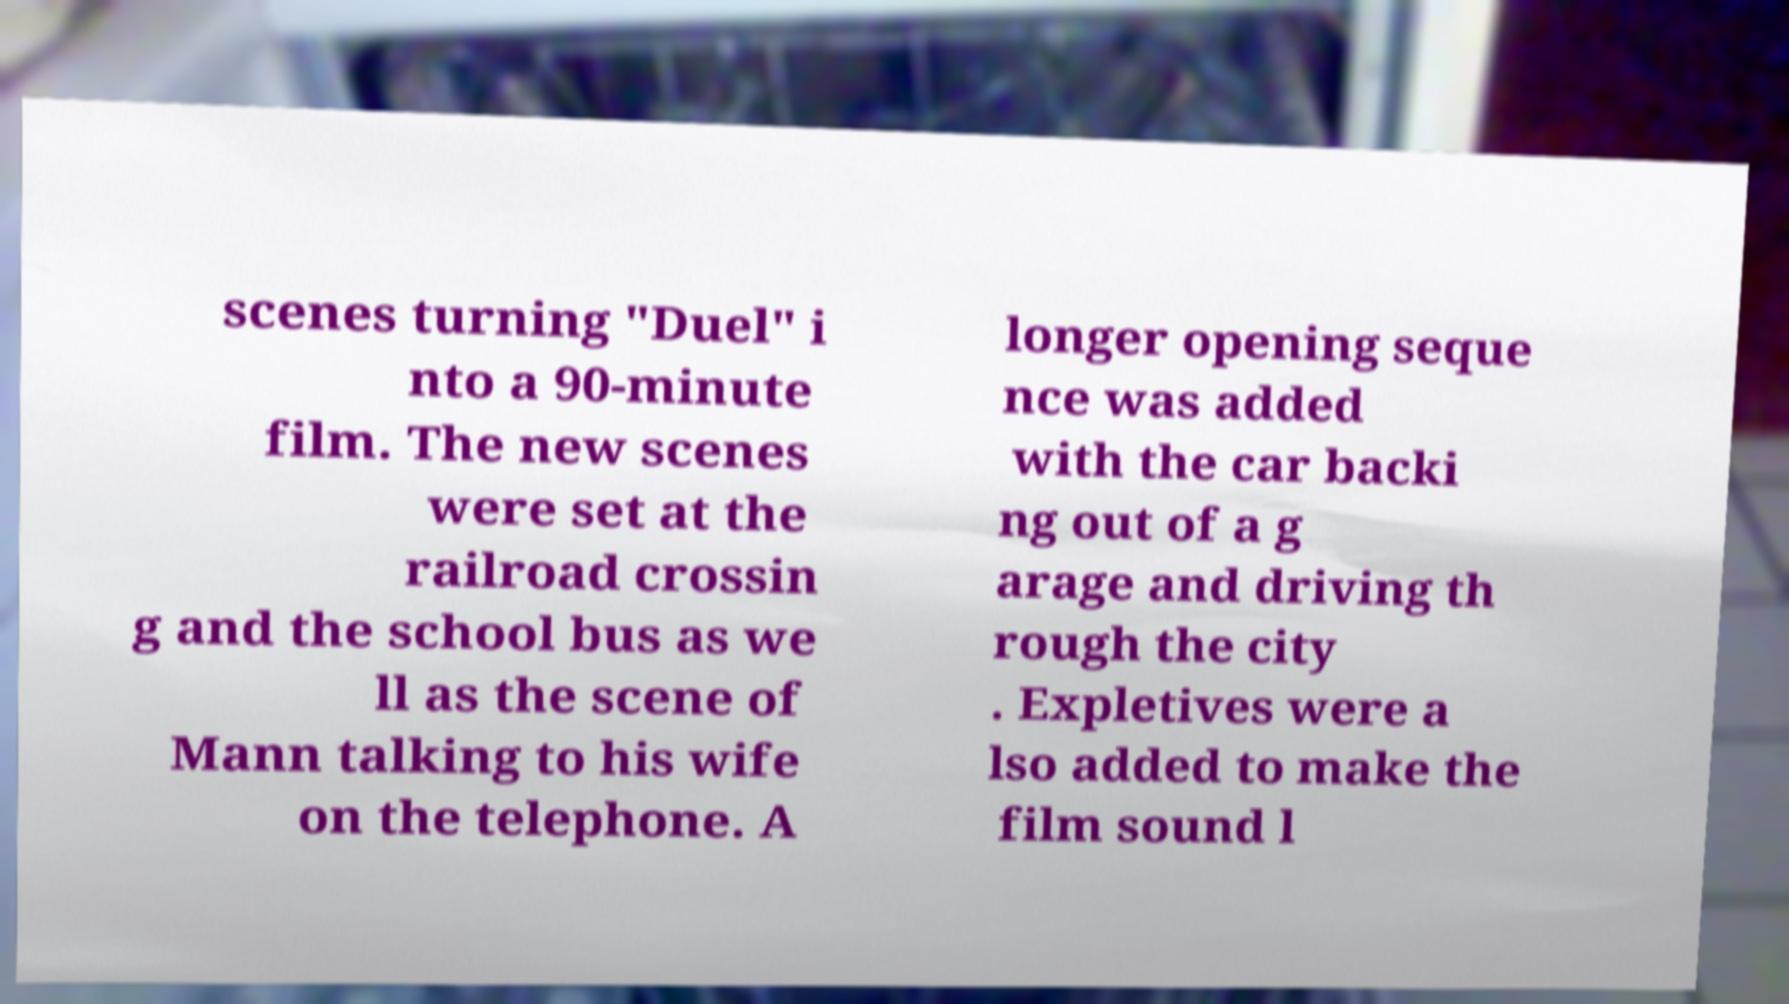Could you assist in decoding the text presented in this image and type it out clearly? scenes turning "Duel" i nto a 90-minute film. The new scenes were set at the railroad crossin g and the school bus as we ll as the scene of Mann talking to his wife on the telephone. A longer opening seque nce was added with the car backi ng out of a g arage and driving th rough the city . Expletives were a lso added to make the film sound l 